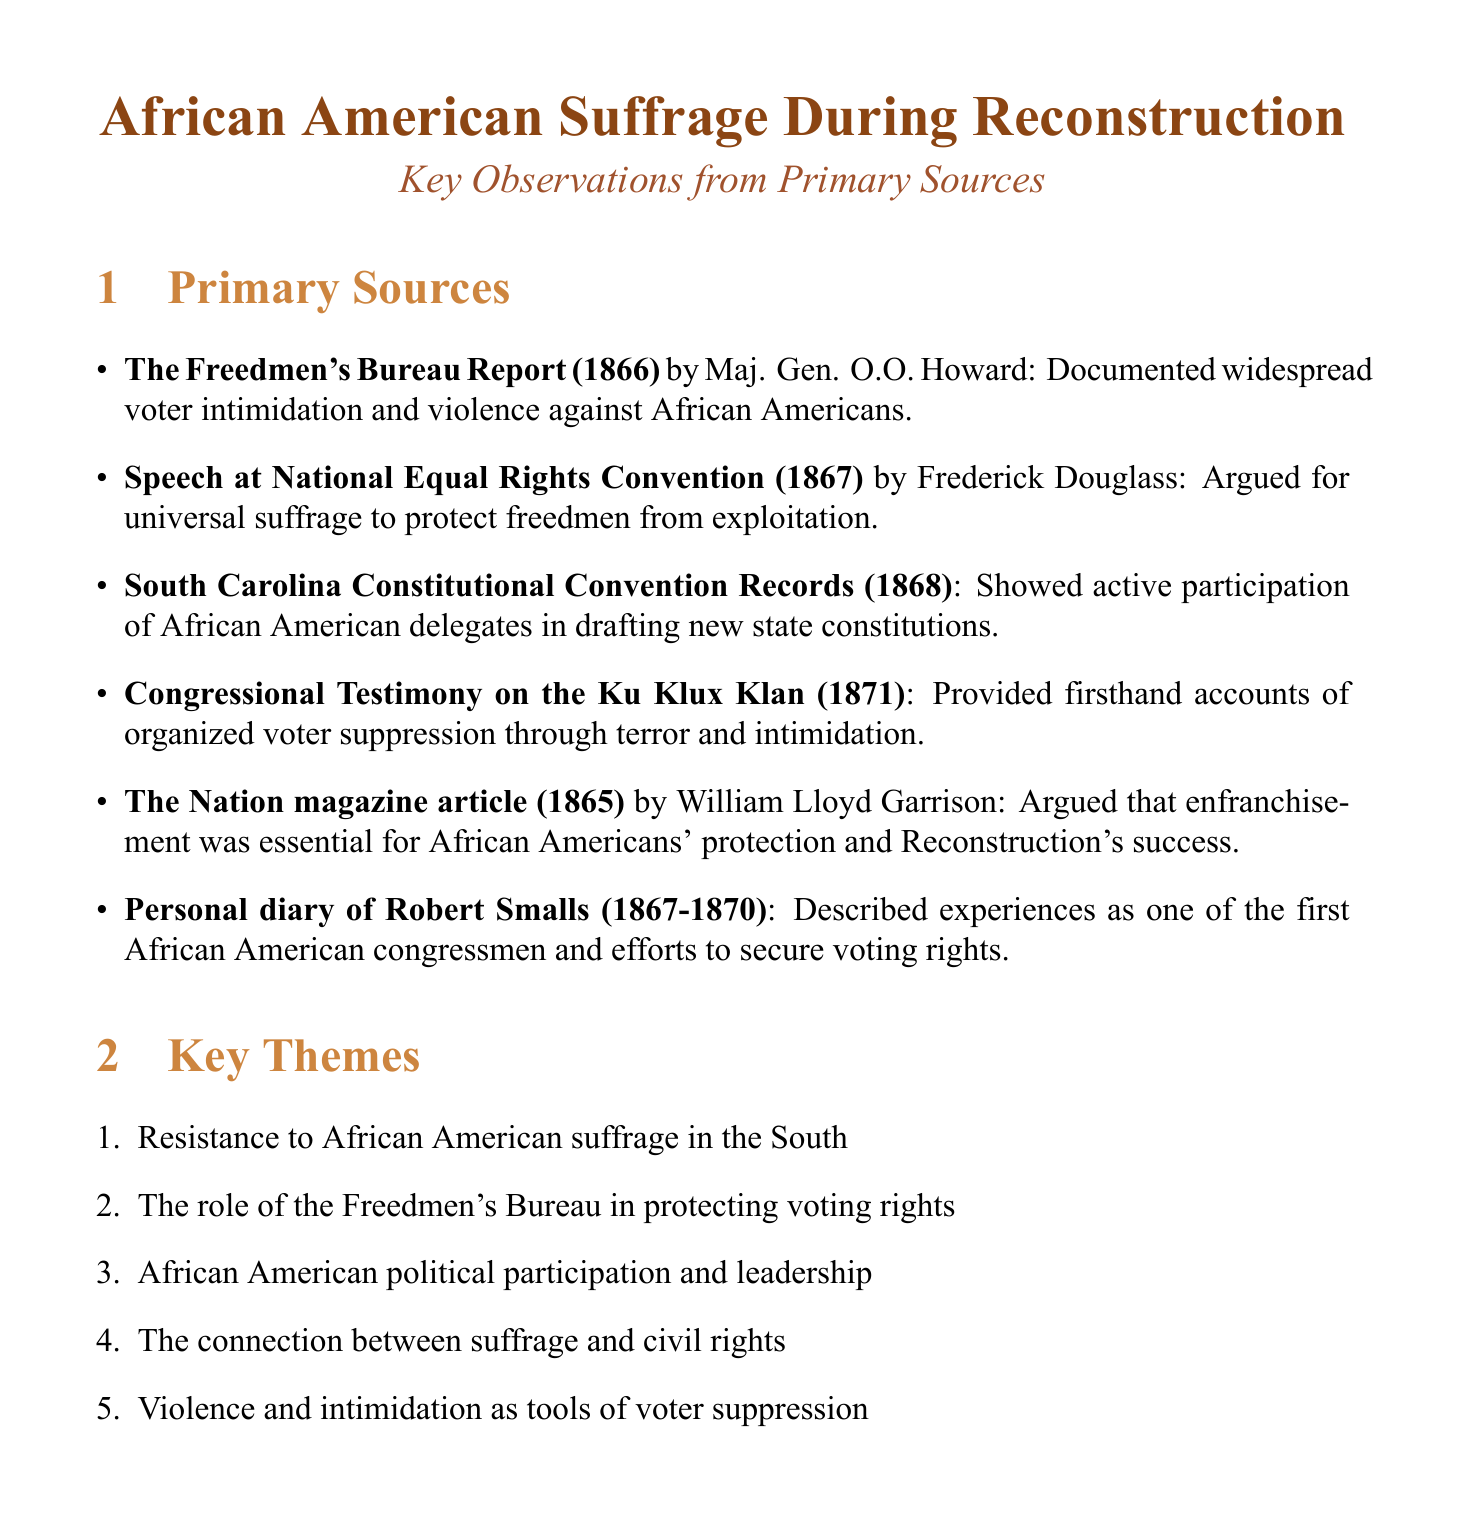What is the author of "The Freedmen's Bureau Report"? The author is Major General O.O. Howard, as stated in the document.
Answer: Major General O.O. Howard What year was the speech at the National Equal Rights Convention given? The speech was given in 1867, according to the document.
Answer: 1867 What did the South Carolina Constitutional Convention Records reveal? They revealed the election of African American delegates, as mentioned in the document.
Answer: Election of African American delegates What is one key theme identified in the document? One key theme is "Resistance to African American suffrage in the South," which is listed in the themes section.
Answer: Resistance to African American suffrage in the South Who wrote the article in The Nation magazine? The article was written by William Lloyd Garrison, as specified in the document.
Answer: William Lloyd Garrison In what years does Robert Smalls' personal diary span? The diary spans from 1867 to 1870, according to the document.
Answer: 1867-1870 What organized group is mentioned as suppressing African American voting? The document mentions the Ku Klux Klan as the group involved in suppression.
Answer: Ku Klux Klan What was a major challenge faced by African Americans attempting to vote? The document notes "widespread voter intimidation and violence" as a major challenge.
Answer: Voter intimidation and violence 